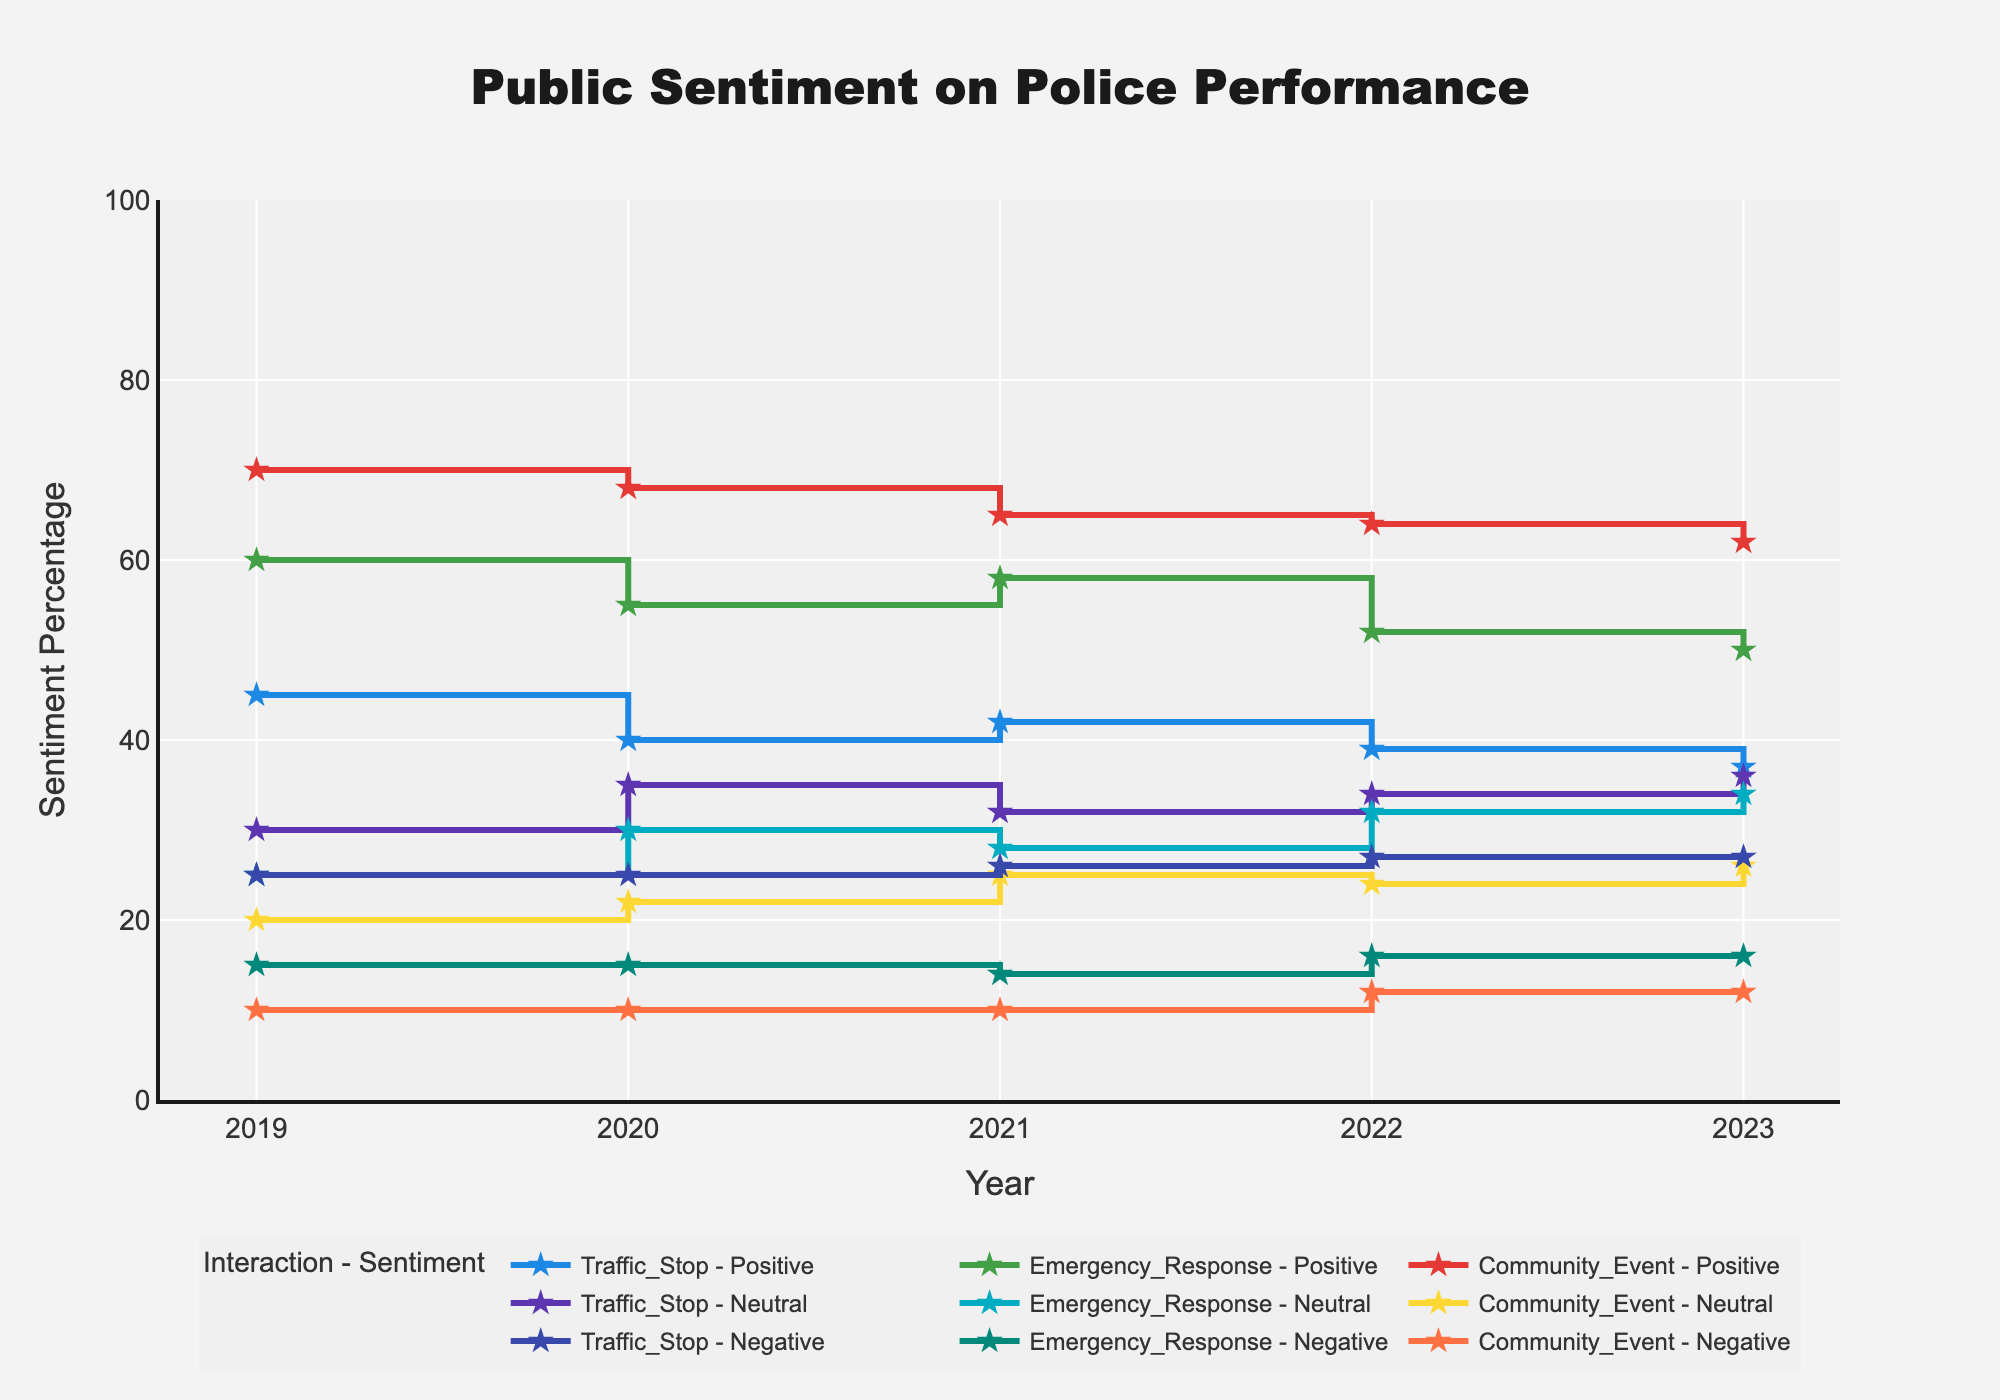What is the overall trend of positive sentiment for Traffic Stops from 2019 to 2023? The positive sentiment for Traffic Stops shows a decreasing trend from 45% in 2019 to 37% in 2023.
Answer: Decreasing trend Which interaction type had the highest positive sentiment in 2023? Community Event had the highest positive sentiment in 2023 with 62%.
Answer: Community Event Compare the negative sentiment between Emergency Response and Traffic Stop in 2021. Which has a higher value and by how much? In 2021, the negative sentiment for Emergency Response is 14%, and for Traffic Stop, it is 26%. The Traffic Stop has a higher negative sentiment by 12%.
Answer: Traffic Stop, 12% What is the range of neutral sentiment for Community Events across the years? The neutral sentiment for Community Events is 20% in 2019, 22% in 2020, 25% in 2021, 24% in 2022, and 26% in 2023. The range is from 20% to 26%.
Answer: 20% to 26% Which year had the lowest positive sentiment for Emergency Response and what was the value? The year 2023 had the lowest positive sentiment for Emergency Response at 50%.
Answer: 2023, 50% How does the positive sentiment for Traffic Stops in 2020 compare to that in 2019? Positive sentiment for Traffic Stops in 2020 was 40%, whereas in 2019, it was 45%. There is a decrease of 5%.
Answer: 5% decrease Across all the years, which interaction type has the most consistent negative sentiment values? Community Event has the most consistent negative sentiment values, remaining between 10% and 12% from 2019 to 2023.
Answer: Community Event What is the average positive sentiment for Community Events from 2019 to 2023? Positive sentiment for Community Events is 70% in 2019, 68% in 2020, 65% in 2021, 64% in 2022, and 62% in 2023. The average is (70+68+65+64+62)/5 = 65.8%.
Answer: 65.8% What is the difference in positive sentiment for Emergency Response between 2020 and 2021? In 2020, the positive sentiment for Emergency Response was 55%, and in 2021, it was 58%. The difference is 58% - 55% = 3%.
Answer: 3% Which sentiment type shows the highest variation over the years for Traffic Stops? The positive sentiment for Traffic Stops varies from 45% in 2019 to 37% in 2023, showing the highest variation compared to other sentiment types for Traffic Stops.
Answer: Positive sentiment 